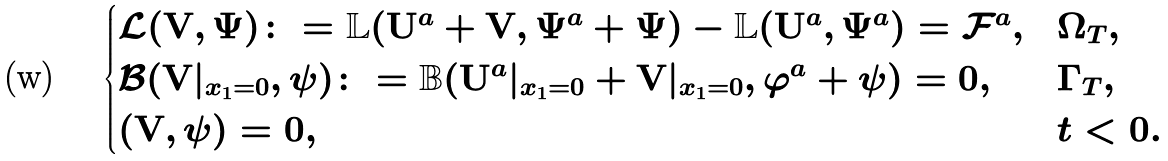Convert formula to latex. <formula><loc_0><loc_0><loc_500><loc_500>\begin{cases} \mathcal { L } ( { \mathbf V } , \Psi ) \colon = \mathbb { L } ( { \mathbf U } ^ { a } + { \mathbf V } , \Psi ^ { a } + \Psi ) - \mathbb { L } ( { \mathbf U } ^ { a } , \Psi ^ { a } ) = \mathcal { F } ^ { a } , & \Omega _ { T } , \\ \mathcal { B } ( { \mathbf V } | _ { x _ { 1 } = 0 } , \psi ) \colon = \mathbb { B } ( { \mathbf U } ^ { a } | _ { x _ { 1 } = 0 } + { \mathbf V } | _ { x _ { 1 } = 0 } , \varphi ^ { a } + \psi ) = 0 , & \Gamma _ { T } , \\ ( { \mathbf V } , \psi ) = 0 , & t < 0 . \end{cases}</formula> 